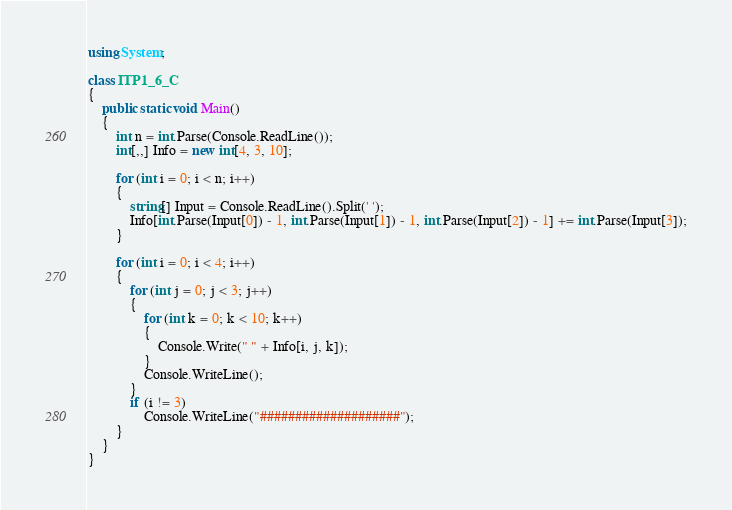<code> <loc_0><loc_0><loc_500><loc_500><_C#_>using System;

class ITP1_6_C
{
    public static void Main()
    {
        int n = int.Parse(Console.ReadLine());
        int[,,] Info = new int[4, 3, 10];

        for (int i = 0; i < n; i++)
        {
            string[] Input = Console.ReadLine().Split(' ');
            Info[int.Parse(Input[0]) - 1, int.Parse(Input[1]) - 1, int.Parse(Input[2]) - 1] += int.Parse(Input[3]);
        }

        for (int i = 0; i < 4; i++)
        {
            for (int j = 0; j < 3; j++)
            {
                for (int k = 0; k < 10; k++)
                {
                    Console.Write(" " + Info[i, j, k]);
                }
                Console.WriteLine();
            }
            if (i != 3)
                Console.WriteLine("####################");
        }
    }
}</code> 